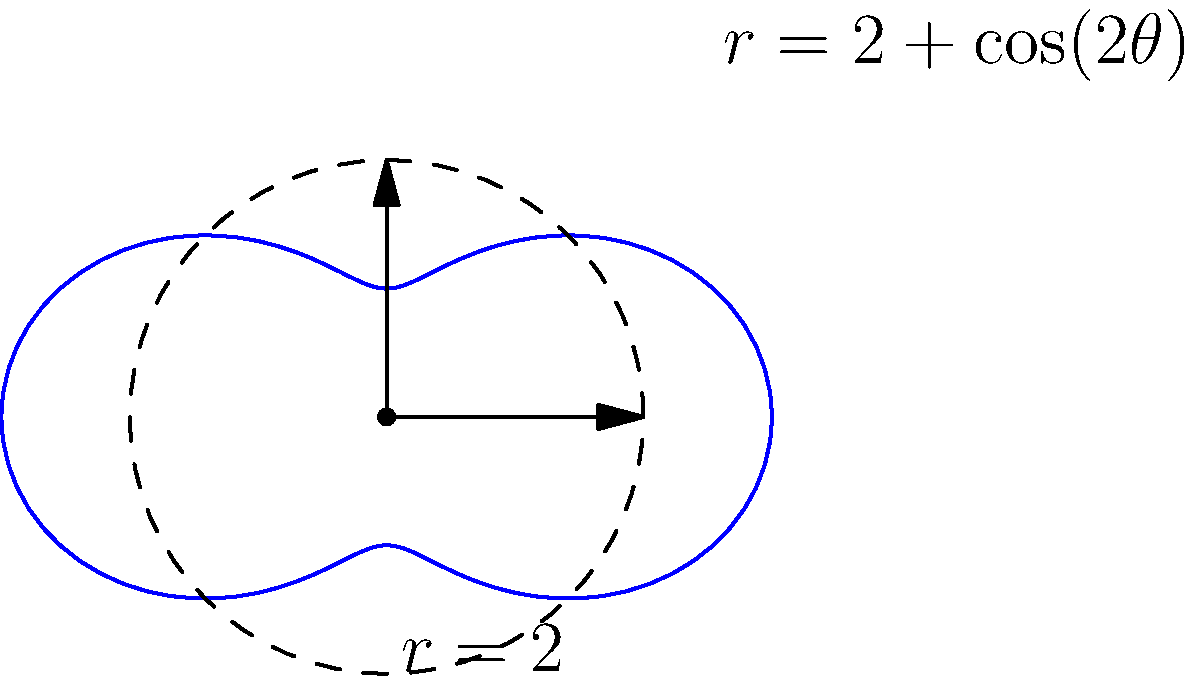In a circular composite material, the stress distribution is modeled by the equation $r = 2 + \cos(2\theta)$ in polar coordinates, where $r$ represents the stress magnitude and $\theta$ is the angular position. How does the maximum stress compare to the minimum stress, and at which angles do they occur? Consider the implications for material design and potential failure points. To solve this problem, we need to follow these steps:

1) The stress distribution is given by $r = 2 + \cos(2\theta)$.

2) To find the maximum and minimum stress, we need to find the maximum and minimum values of $r$.

3) The function $\cos(2\theta)$ oscillates between -1 and 1. Therefore:
   - Maximum stress: $r_{max} = 2 + 1 = 3$
   - Minimum stress: $r_{min} = 2 - 1 = 1$

4) To find the angles at which these occur:
   - Maximum stress occurs when $\cos(2\theta) = 1$, which happens when $2\theta = 0, 2\pi, 4\pi, ...$
     So, $\theta = 0, \pi, 2\pi, ...$
   - Minimum stress occurs when $\cos(2\theta) = -1$, which happens when $2\theta = \pi, 3\pi, 5\pi, ...$
     So, $\theta = \frac{\pi}{2}, \frac{3\pi}{2}, \frac{5\pi}{2}, ...$

5) The ratio of maximum to minimum stress is $\frac{r_{max}}{r_{min}} = \frac{3}{1} = 3$.

6) Implications for material design:
   - The material experiences 3 times more stress at certain points (θ = 0, π) compared to others (θ = π/2, 3π/2).
   - This stress concentration could lead to potential failure points at θ = 0 and π.
   - Designers might need to reinforce the material at these high-stress points or consider a different design to distribute stress more evenly.
Answer: Maximum stress is 3 times minimum stress. Max occurs at θ = 0, π; min at θ = π/2, 3π/2. Design implications: reinforce at θ = 0, π to prevent failure. 